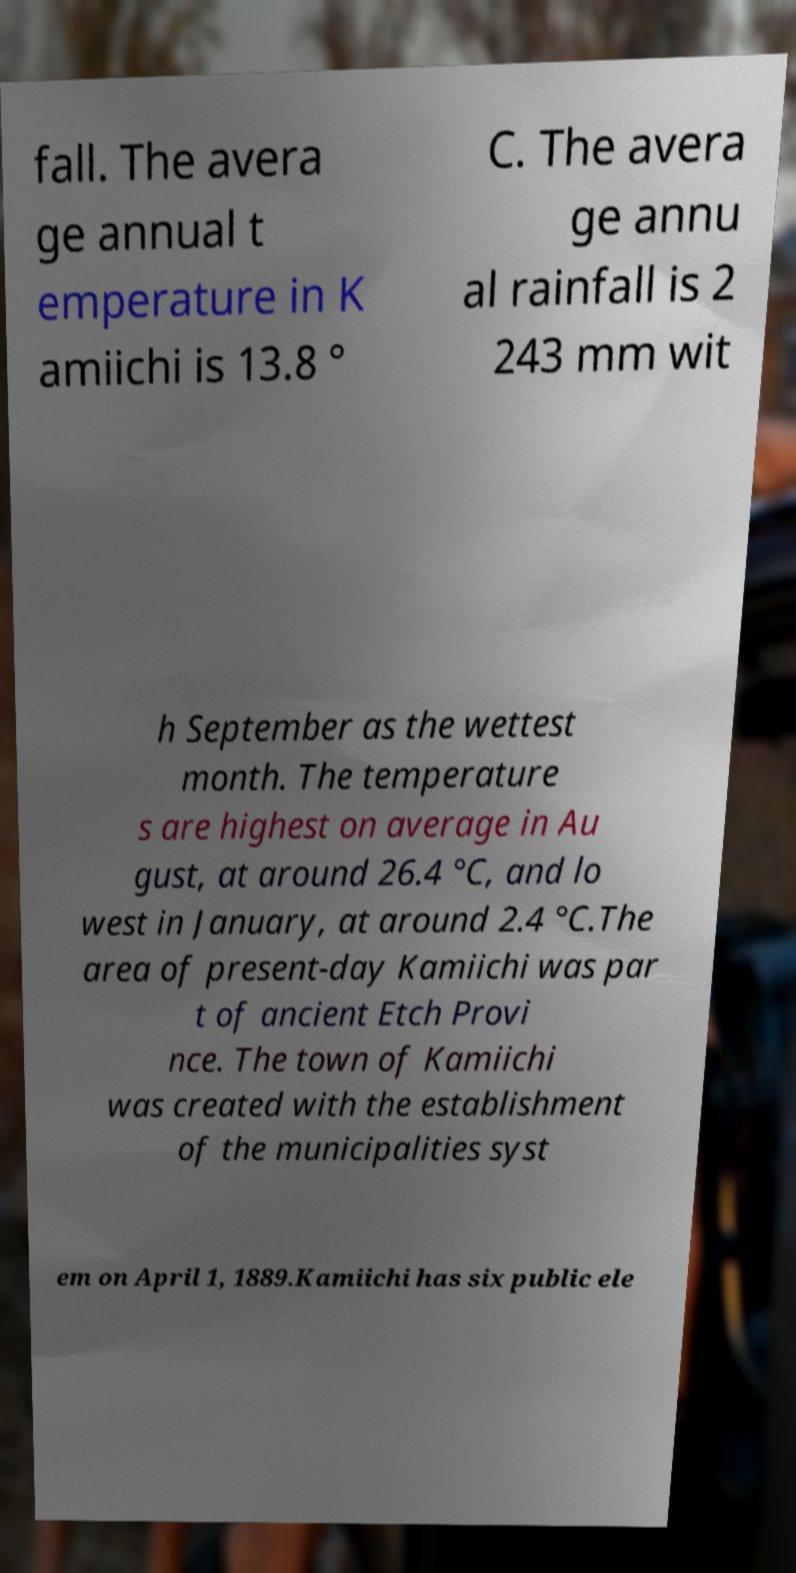What messages or text are displayed in this image? I need them in a readable, typed format. fall. The avera ge annual t emperature in K amiichi is 13.8 ° C. The avera ge annu al rainfall is 2 243 mm wit h September as the wettest month. The temperature s are highest on average in Au gust, at around 26.4 °C, and lo west in January, at around 2.4 °C.The area of present-day Kamiichi was par t of ancient Etch Provi nce. The town of Kamiichi was created with the establishment of the municipalities syst em on April 1, 1889.Kamiichi has six public ele 